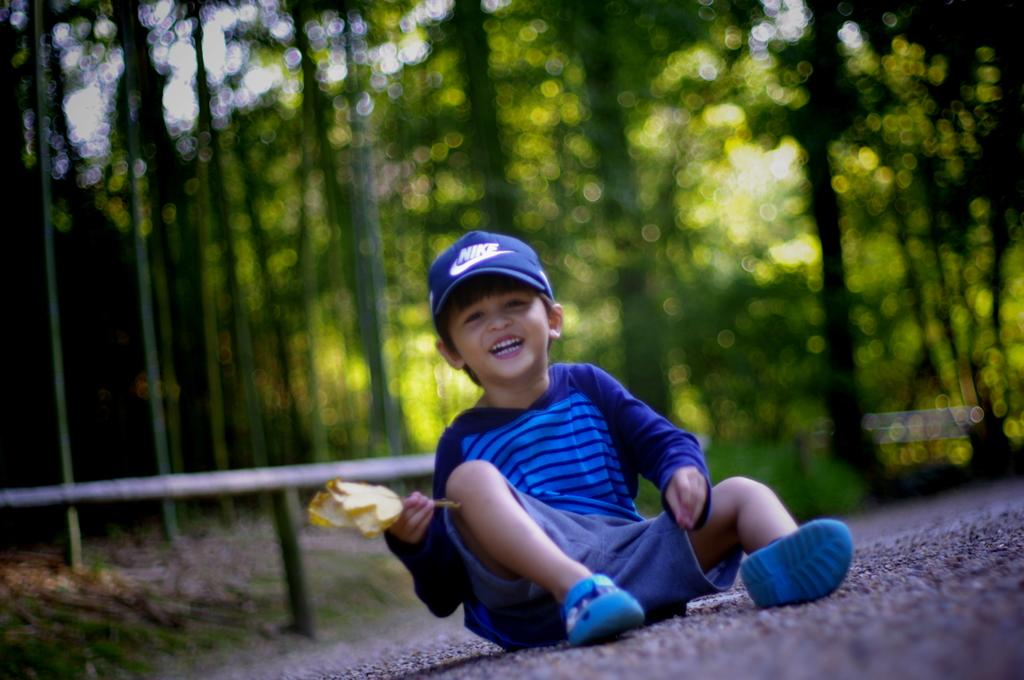Who is the main subject in the image? There is a boy in the image. What is the boy doing in the image? The boy is sitting on the road and holding a flower. What is the boy wearing in the image? The boy is wearing a blue shirt and a blue cap. What can be seen in the background of the image? There are trees in the background of the image. What type of stick is the boy using to bite into the yam in the image? There is no stick or yam present in the image; the boy is holding a flower. 